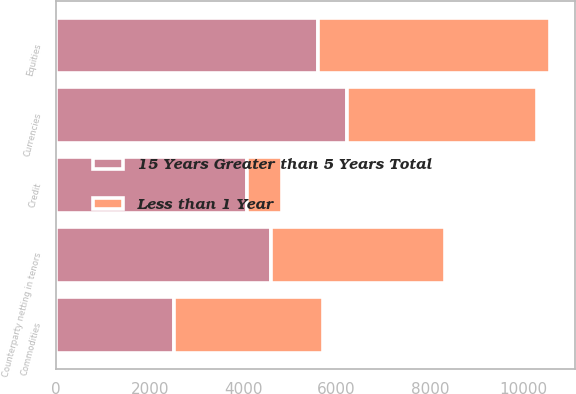<chart> <loc_0><loc_0><loc_500><loc_500><stacked_bar_chart><ecel><fcel>Credit<fcel>Currencies<fcel>Commodities<fcel>Equities<fcel>Counterparty netting in tenors<nl><fcel>Less than 1 Year<fcel>760<fcel>4079<fcel>3175<fcel>4969<fcel>3719<nl><fcel>15 Years Greater than 5 Years Total<fcel>4079<fcel>6219<fcel>2526<fcel>5607<fcel>4594<nl></chart> 